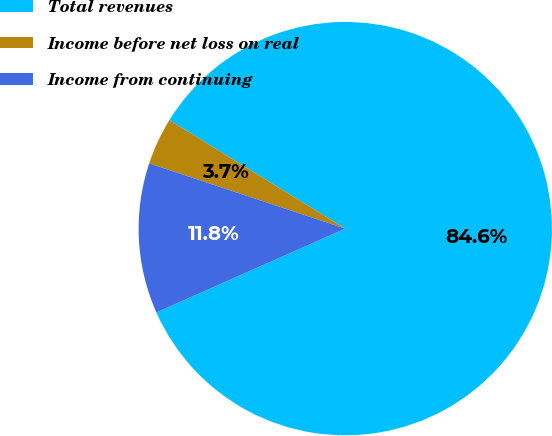<chart> <loc_0><loc_0><loc_500><loc_500><pie_chart><fcel>Total revenues<fcel>Income before net loss on real<fcel>Income from continuing<nl><fcel>84.56%<fcel>3.68%<fcel>11.76%<nl></chart> 